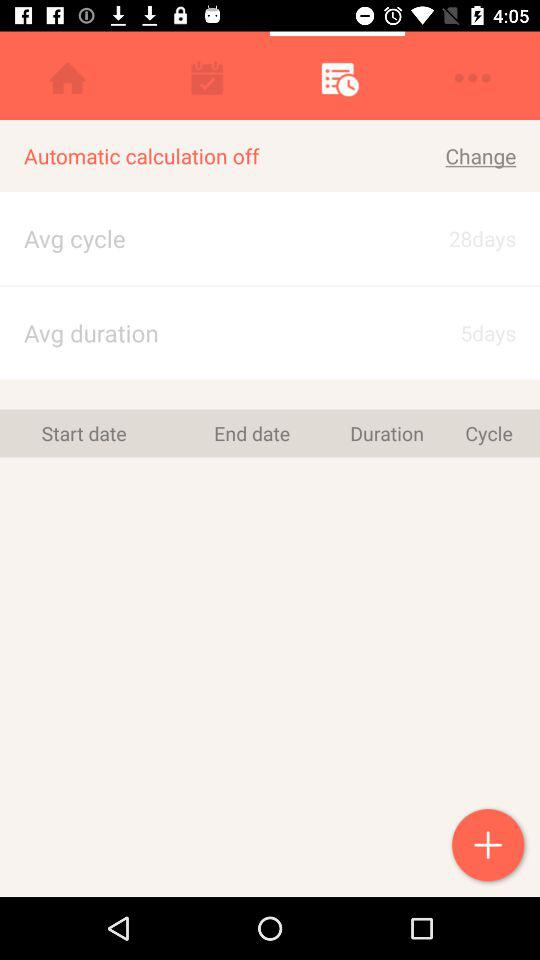What is the current state of "Automatic calculation"? The current state is "off". 